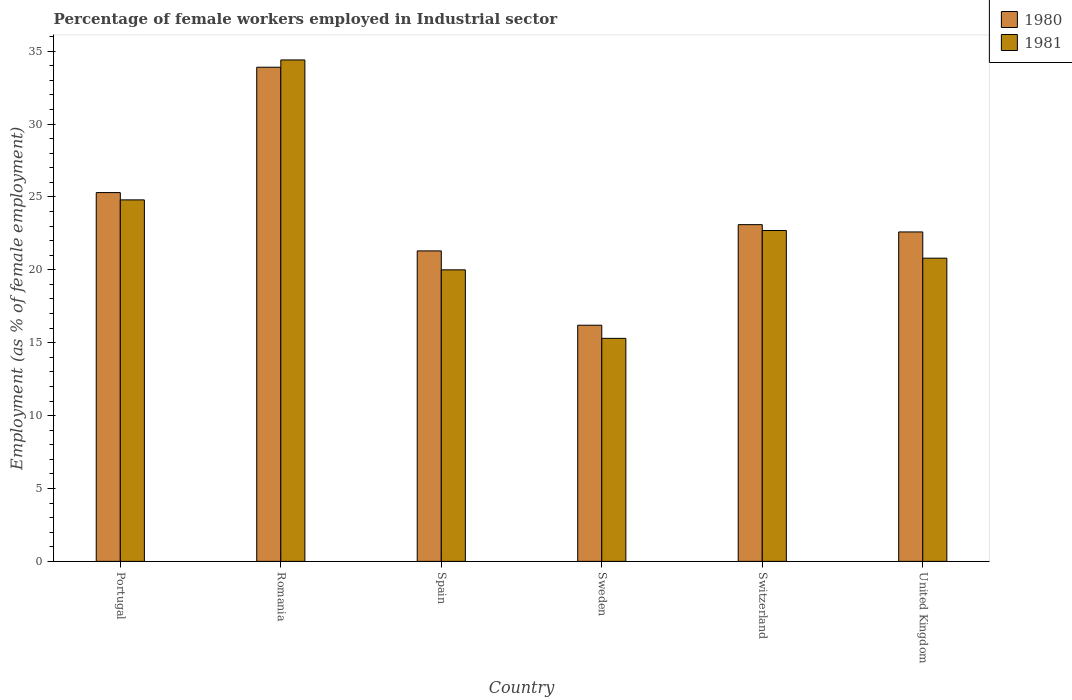How many groups of bars are there?
Your response must be concise. 6. Are the number of bars per tick equal to the number of legend labels?
Keep it short and to the point. Yes. How many bars are there on the 5th tick from the left?
Offer a very short reply. 2. How many bars are there on the 6th tick from the right?
Your answer should be compact. 2. What is the label of the 2nd group of bars from the left?
Make the answer very short. Romania. What is the percentage of females employed in Industrial sector in 1981 in Spain?
Make the answer very short. 20. Across all countries, what is the maximum percentage of females employed in Industrial sector in 1980?
Keep it short and to the point. 33.9. Across all countries, what is the minimum percentage of females employed in Industrial sector in 1980?
Offer a very short reply. 16.2. In which country was the percentage of females employed in Industrial sector in 1981 maximum?
Provide a succinct answer. Romania. What is the total percentage of females employed in Industrial sector in 1981 in the graph?
Provide a succinct answer. 138. What is the difference between the percentage of females employed in Industrial sector in 1981 in Portugal and that in Romania?
Provide a short and direct response. -9.6. What is the difference between the percentage of females employed in Industrial sector in 1981 in Sweden and the percentage of females employed in Industrial sector in 1980 in Spain?
Provide a short and direct response. -6. What is the average percentage of females employed in Industrial sector in 1981 per country?
Offer a terse response. 23. What is the difference between the percentage of females employed in Industrial sector of/in 1981 and percentage of females employed in Industrial sector of/in 1980 in Spain?
Keep it short and to the point. -1.3. In how many countries, is the percentage of females employed in Industrial sector in 1981 greater than 4 %?
Ensure brevity in your answer.  6. What is the ratio of the percentage of females employed in Industrial sector in 1980 in Romania to that in United Kingdom?
Offer a very short reply. 1.5. Is the percentage of females employed in Industrial sector in 1981 in Portugal less than that in United Kingdom?
Give a very brief answer. No. Is the difference between the percentage of females employed in Industrial sector in 1981 in Sweden and Switzerland greater than the difference between the percentage of females employed in Industrial sector in 1980 in Sweden and Switzerland?
Keep it short and to the point. No. What is the difference between the highest and the second highest percentage of females employed in Industrial sector in 1980?
Your answer should be very brief. 8.6. What is the difference between the highest and the lowest percentage of females employed in Industrial sector in 1981?
Your answer should be compact. 19.1. In how many countries, is the percentage of females employed in Industrial sector in 1981 greater than the average percentage of females employed in Industrial sector in 1981 taken over all countries?
Your answer should be compact. 2. Is the sum of the percentage of females employed in Industrial sector in 1980 in Romania and Switzerland greater than the maximum percentage of females employed in Industrial sector in 1981 across all countries?
Your answer should be very brief. Yes. What does the 1st bar from the left in Spain represents?
Your answer should be very brief. 1980. How many bars are there?
Offer a terse response. 12. How many countries are there in the graph?
Offer a very short reply. 6. Are the values on the major ticks of Y-axis written in scientific E-notation?
Offer a terse response. No. Where does the legend appear in the graph?
Your response must be concise. Top right. How many legend labels are there?
Your answer should be very brief. 2. How are the legend labels stacked?
Ensure brevity in your answer.  Vertical. What is the title of the graph?
Offer a terse response. Percentage of female workers employed in Industrial sector. What is the label or title of the Y-axis?
Give a very brief answer. Employment (as % of female employment). What is the Employment (as % of female employment) of 1980 in Portugal?
Your answer should be compact. 25.3. What is the Employment (as % of female employment) of 1981 in Portugal?
Ensure brevity in your answer.  24.8. What is the Employment (as % of female employment) in 1980 in Romania?
Your response must be concise. 33.9. What is the Employment (as % of female employment) of 1981 in Romania?
Offer a terse response. 34.4. What is the Employment (as % of female employment) of 1980 in Spain?
Offer a terse response. 21.3. What is the Employment (as % of female employment) of 1980 in Sweden?
Your answer should be very brief. 16.2. What is the Employment (as % of female employment) in 1981 in Sweden?
Provide a succinct answer. 15.3. What is the Employment (as % of female employment) in 1980 in Switzerland?
Ensure brevity in your answer.  23.1. What is the Employment (as % of female employment) of 1981 in Switzerland?
Provide a succinct answer. 22.7. What is the Employment (as % of female employment) of 1980 in United Kingdom?
Provide a short and direct response. 22.6. What is the Employment (as % of female employment) of 1981 in United Kingdom?
Your response must be concise. 20.8. Across all countries, what is the maximum Employment (as % of female employment) of 1980?
Provide a succinct answer. 33.9. Across all countries, what is the maximum Employment (as % of female employment) of 1981?
Your answer should be very brief. 34.4. Across all countries, what is the minimum Employment (as % of female employment) of 1980?
Your answer should be compact. 16.2. Across all countries, what is the minimum Employment (as % of female employment) of 1981?
Keep it short and to the point. 15.3. What is the total Employment (as % of female employment) of 1980 in the graph?
Ensure brevity in your answer.  142.4. What is the total Employment (as % of female employment) of 1981 in the graph?
Your response must be concise. 138. What is the difference between the Employment (as % of female employment) in 1980 in Portugal and that in Romania?
Keep it short and to the point. -8.6. What is the difference between the Employment (as % of female employment) of 1981 in Portugal and that in Romania?
Your answer should be compact. -9.6. What is the difference between the Employment (as % of female employment) of 1980 in Portugal and that in Spain?
Keep it short and to the point. 4. What is the difference between the Employment (as % of female employment) of 1981 in Portugal and that in Spain?
Keep it short and to the point. 4.8. What is the difference between the Employment (as % of female employment) of 1980 in Portugal and that in Switzerland?
Offer a terse response. 2.2. What is the difference between the Employment (as % of female employment) of 1981 in Portugal and that in Switzerland?
Keep it short and to the point. 2.1. What is the difference between the Employment (as % of female employment) of 1981 in Portugal and that in United Kingdom?
Keep it short and to the point. 4. What is the difference between the Employment (as % of female employment) of 1980 in Romania and that in Spain?
Ensure brevity in your answer.  12.6. What is the difference between the Employment (as % of female employment) in 1981 in Romania and that in Spain?
Make the answer very short. 14.4. What is the difference between the Employment (as % of female employment) in 1980 in Romania and that in Sweden?
Offer a very short reply. 17.7. What is the difference between the Employment (as % of female employment) of 1981 in Romania and that in Sweden?
Your answer should be very brief. 19.1. What is the difference between the Employment (as % of female employment) in 1980 in Romania and that in Switzerland?
Your response must be concise. 10.8. What is the difference between the Employment (as % of female employment) in 1980 in Romania and that in United Kingdom?
Give a very brief answer. 11.3. What is the difference between the Employment (as % of female employment) of 1980 in Spain and that in Switzerland?
Provide a succinct answer. -1.8. What is the difference between the Employment (as % of female employment) of 1981 in Spain and that in Switzerland?
Your answer should be compact. -2.7. What is the difference between the Employment (as % of female employment) of 1980 in Spain and that in United Kingdom?
Provide a short and direct response. -1.3. What is the difference between the Employment (as % of female employment) in 1980 in Sweden and that in Switzerland?
Provide a short and direct response. -6.9. What is the difference between the Employment (as % of female employment) in 1981 in Sweden and that in Switzerland?
Offer a terse response. -7.4. What is the difference between the Employment (as % of female employment) in 1980 in Switzerland and that in United Kingdom?
Keep it short and to the point. 0.5. What is the difference between the Employment (as % of female employment) in 1980 in Portugal and the Employment (as % of female employment) in 1981 in Romania?
Provide a short and direct response. -9.1. What is the difference between the Employment (as % of female employment) of 1980 in Portugal and the Employment (as % of female employment) of 1981 in Switzerland?
Your answer should be very brief. 2.6. What is the difference between the Employment (as % of female employment) in 1980 in Portugal and the Employment (as % of female employment) in 1981 in United Kingdom?
Offer a very short reply. 4.5. What is the difference between the Employment (as % of female employment) in 1980 in Romania and the Employment (as % of female employment) in 1981 in Spain?
Provide a succinct answer. 13.9. What is the difference between the Employment (as % of female employment) of 1980 in Romania and the Employment (as % of female employment) of 1981 in Sweden?
Give a very brief answer. 18.6. What is the difference between the Employment (as % of female employment) of 1980 in Romania and the Employment (as % of female employment) of 1981 in Switzerland?
Provide a succinct answer. 11.2. What is the difference between the Employment (as % of female employment) in 1980 in Romania and the Employment (as % of female employment) in 1981 in United Kingdom?
Offer a terse response. 13.1. What is the difference between the Employment (as % of female employment) in 1980 in Spain and the Employment (as % of female employment) in 1981 in Sweden?
Your response must be concise. 6. What is the average Employment (as % of female employment) in 1980 per country?
Your answer should be compact. 23.73. What is the average Employment (as % of female employment) in 1981 per country?
Make the answer very short. 23. What is the difference between the Employment (as % of female employment) in 1980 and Employment (as % of female employment) in 1981 in Romania?
Give a very brief answer. -0.5. What is the difference between the Employment (as % of female employment) of 1980 and Employment (as % of female employment) of 1981 in Switzerland?
Your answer should be compact. 0.4. What is the ratio of the Employment (as % of female employment) in 1980 in Portugal to that in Romania?
Your response must be concise. 0.75. What is the ratio of the Employment (as % of female employment) of 1981 in Portugal to that in Romania?
Keep it short and to the point. 0.72. What is the ratio of the Employment (as % of female employment) in 1980 in Portugal to that in Spain?
Offer a very short reply. 1.19. What is the ratio of the Employment (as % of female employment) of 1981 in Portugal to that in Spain?
Provide a succinct answer. 1.24. What is the ratio of the Employment (as % of female employment) in 1980 in Portugal to that in Sweden?
Provide a short and direct response. 1.56. What is the ratio of the Employment (as % of female employment) of 1981 in Portugal to that in Sweden?
Keep it short and to the point. 1.62. What is the ratio of the Employment (as % of female employment) of 1980 in Portugal to that in Switzerland?
Give a very brief answer. 1.1. What is the ratio of the Employment (as % of female employment) of 1981 in Portugal to that in Switzerland?
Make the answer very short. 1.09. What is the ratio of the Employment (as % of female employment) in 1980 in Portugal to that in United Kingdom?
Make the answer very short. 1.12. What is the ratio of the Employment (as % of female employment) of 1981 in Portugal to that in United Kingdom?
Offer a very short reply. 1.19. What is the ratio of the Employment (as % of female employment) in 1980 in Romania to that in Spain?
Offer a very short reply. 1.59. What is the ratio of the Employment (as % of female employment) of 1981 in Romania to that in Spain?
Give a very brief answer. 1.72. What is the ratio of the Employment (as % of female employment) in 1980 in Romania to that in Sweden?
Offer a terse response. 2.09. What is the ratio of the Employment (as % of female employment) of 1981 in Romania to that in Sweden?
Your answer should be compact. 2.25. What is the ratio of the Employment (as % of female employment) of 1980 in Romania to that in Switzerland?
Your answer should be compact. 1.47. What is the ratio of the Employment (as % of female employment) in 1981 in Romania to that in Switzerland?
Your answer should be very brief. 1.52. What is the ratio of the Employment (as % of female employment) of 1981 in Romania to that in United Kingdom?
Your answer should be compact. 1.65. What is the ratio of the Employment (as % of female employment) in 1980 in Spain to that in Sweden?
Your answer should be very brief. 1.31. What is the ratio of the Employment (as % of female employment) in 1981 in Spain to that in Sweden?
Provide a succinct answer. 1.31. What is the ratio of the Employment (as % of female employment) of 1980 in Spain to that in Switzerland?
Your answer should be very brief. 0.92. What is the ratio of the Employment (as % of female employment) of 1981 in Spain to that in Switzerland?
Ensure brevity in your answer.  0.88. What is the ratio of the Employment (as % of female employment) in 1980 in Spain to that in United Kingdom?
Make the answer very short. 0.94. What is the ratio of the Employment (as % of female employment) of 1981 in Spain to that in United Kingdom?
Offer a terse response. 0.96. What is the ratio of the Employment (as % of female employment) of 1980 in Sweden to that in Switzerland?
Your answer should be very brief. 0.7. What is the ratio of the Employment (as % of female employment) of 1981 in Sweden to that in Switzerland?
Offer a very short reply. 0.67. What is the ratio of the Employment (as % of female employment) of 1980 in Sweden to that in United Kingdom?
Make the answer very short. 0.72. What is the ratio of the Employment (as % of female employment) in 1981 in Sweden to that in United Kingdom?
Provide a succinct answer. 0.74. What is the ratio of the Employment (as % of female employment) of 1980 in Switzerland to that in United Kingdom?
Your answer should be very brief. 1.02. What is the ratio of the Employment (as % of female employment) in 1981 in Switzerland to that in United Kingdom?
Give a very brief answer. 1.09. What is the difference between the highest and the second highest Employment (as % of female employment) in 1980?
Your answer should be compact. 8.6. What is the difference between the highest and the second highest Employment (as % of female employment) of 1981?
Your response must be concise. 9.6. 